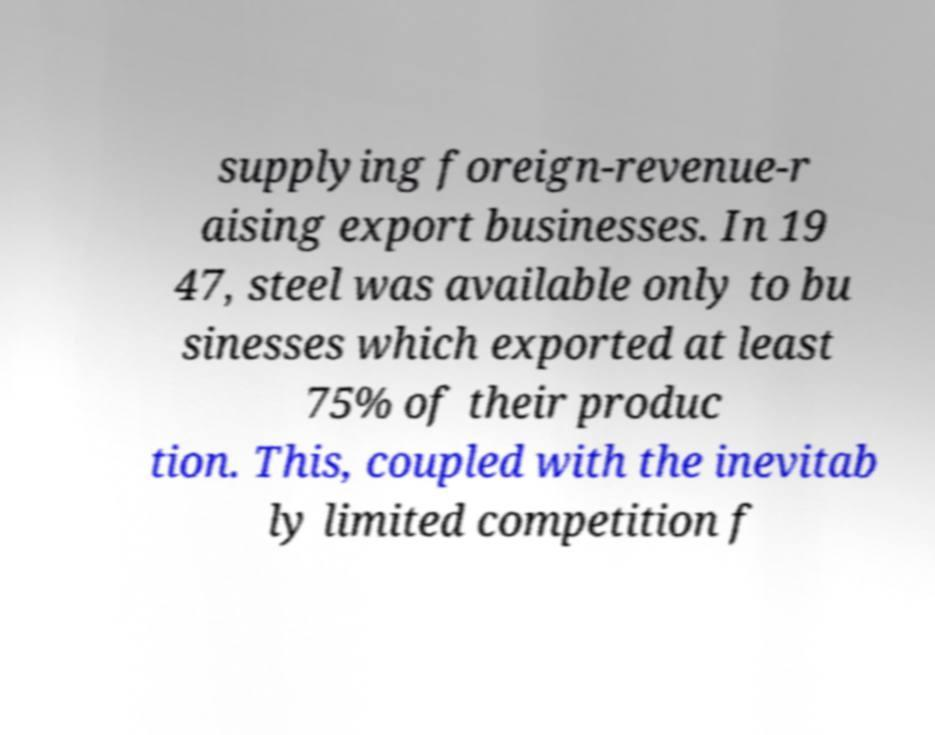What messages or text are displayed in this image? I need them in a readable, typed format. supplying foreign-revenue-r aising export businesses. In 19 47, steel was available only to bu sinesses which exported at least 75% of their produc tion. This, coupled with the inevitab ly limited competition f 